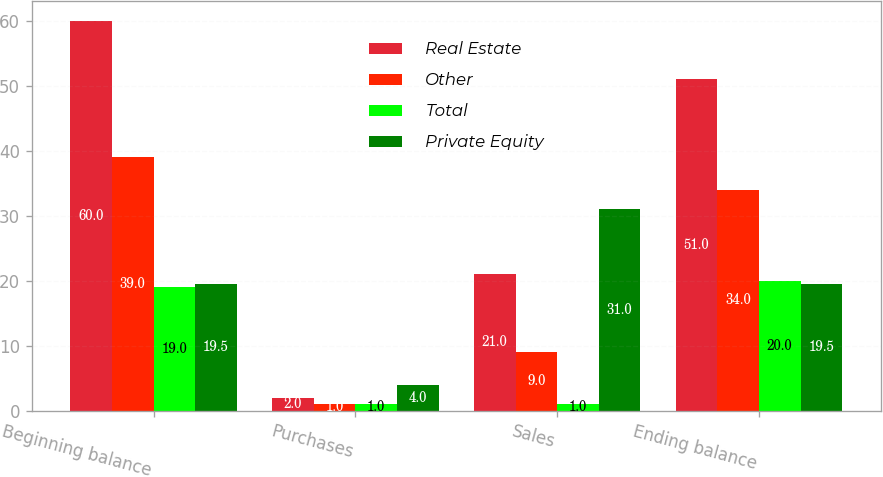Convert chart. <chart><loc_0><loc_0><loc_500><loc_500><stacked_bar_chart><ecel><fcel>Beginning balance<fcel>Purchases<fcel>Sales<fcel>Ending balance<nl><fcel>Real Estate<fcel>60<fcel>2<fcel>21<fcel>51<nl><fcel>Other<fcel>39<fcel>1<fcel>9<fcel>34<nl><fcel>Total<fcel>19<fcel>1<fcel>1<fcel>20<nl><fcel>Private Equity<fcel>19.5<fcel>4<fcel>31<fcel>19.5<nl></chart> 